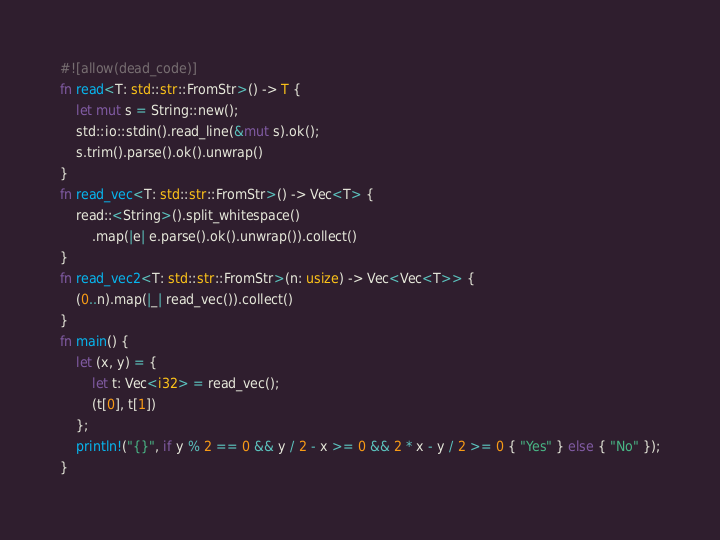<code> <loc_0><loc_0><loc_500><loc_500><_Rust_>#![allow(dead_code)]
fn read<T: std::str::FromStr>() -> T {
    let mut s = String::new();
    std::io::stdin().read_line(&mut s).ok();
    s.trim().parse().ok().unwrap()
}
fn read_vec<T: std::str::FromStr>() -> Vec<T> {
    read::<String>().split_whitespace()
        .map(|e| e.parse().ok().unwrap()).collect()
}
fn read_vec2<T: std::str::FromStr>(n: usize) -> Vec<Vec<T>> {
    (0..n).map(|_| read_vec()).collect()
}
fn main() {
    let (x, y) = {
        let t: Vec<i32> = read_vec();
        (t[0], t[1])
    };
    println!("{}", if y % 2 == 0 && y / 2 - x >= 0 && 2 * x - y / 2 >= 0 { "Yes" } else { "No" });
}</code> 